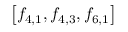Convert formula to latex. <formula><loc_0><loc_0><loc_500><loc_500>\left [ f _ { 4 , 1 } , f _ { 4 , 3 } , f _ { 6 , 1 } \right ]</formula> 